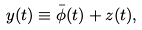<formula> <loc_0><loc_0><loc_500><loc_500>y ( t ) & \equiv \bar { \phi } ( t ) + z ( t ) ,</formula> 